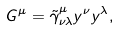Convert formula to latex. <formula><loc_0><loc_0><loc_500><loc_500>G ^ { \mu } = \tilde { \gamma } ^ { \mu } _ { \nu \lambda } y ^ { \nu } y ^ { \lambda } ,</formula> 